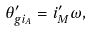<formula> <loc_0><loc_0><loc_500><loc_500>\theta _ { g i _ { A } } ^ { \prime } = i _ { M } ^ { \prime } \omega ,</formula> 